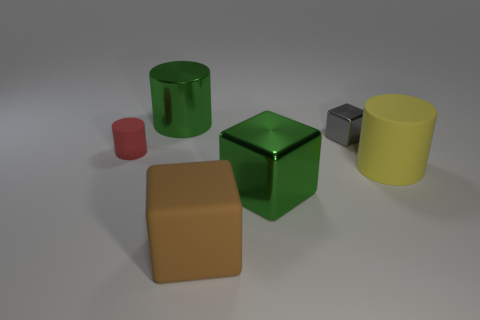Subtract all cyan cylinders. Subtract all gray spheres. How many cylinders are left? 3 Add 4 yellow rubber objects. How many objects exist? 10 Subtract all yellow matte blocks. Subtract all gray shiny things. How many objects are left? 5 Add 1 matte cylinders. How many matte cylinders are left? 3 Add 5 small cylinders. How many small cylinders exist? 6 Subtract 1 yellow cylinders. How many objects are left? 5 